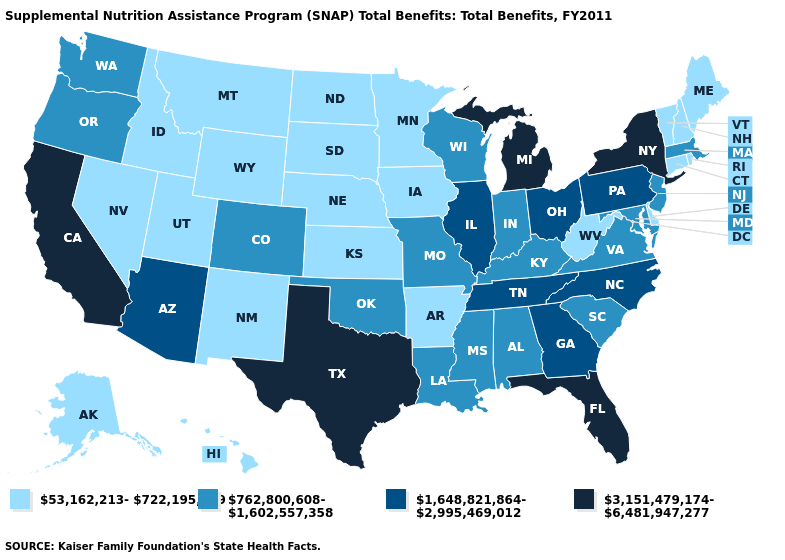Among the states that border Wyoming , which have the highest value?
Quick response, please. Colorado. Name the states that have a value in the range 1,648,821,864-2,995,469,012?
Concise answer only. Arizona, Georgia, Illinois, North Carolina, Ohio, Pennsylvania, Tennessee. What is the value of Rhode Island?
Write a very short answer. 53,162,213-722,195,399. Among the states that border Rhode Island , which have the lowest value?
Keep it brief. Connecticut. Name the states that have a value in the range 53,162,213-722,195,399?
Answer briefly. Alaska, Arkansas, Connecticut, Delaware, Hawaii, Idaho, Iowa, Kansas, Maine, Minnesota, Montana, Nebraska, Nevada, New Hampshire, New Mexico, North Dakota, Rhode Island, South Dakota, Utah, Vermont, West Virginia, Wyoming. Does the first symbol in the legend represent the smallest category?
Short answer required. Yes. Does Arizona have a higher value than Michigan?
Be succinct. No. What is the lowest value in states that border Utah?
Write a very short answer. 53,162,213-722,195,399. What is the lowest value in states that border Maryland?
Answer briefly. 53,162,213-722,195,399. Name the states that have a value in the range 3,151,479,174-6,481,947,277?
Concise answer only. California, Florida, Michigan, New York, Texas. What is the lowest value in the West?
Give a very brief answer. 53,162,213-722,195,399. What is the lowest value in states that border Kentucky?
Write a very short answer. 53,162,213-722,195,399. Name the states that have a value in the range 762,800,608-1,602,557,358?
Answer briefly. Alabama, Colorado, Indiana, Kentucky, Louisiana, Maryland, Massachusetts, Mississippi, Missouri, New Jersey, Oklahoma, Oregon, South Carolina, Virginia, Washington, Wisconsin. What is the value of Wyoming?
Give a very brief answer. 53,162,213-722,195,399. 